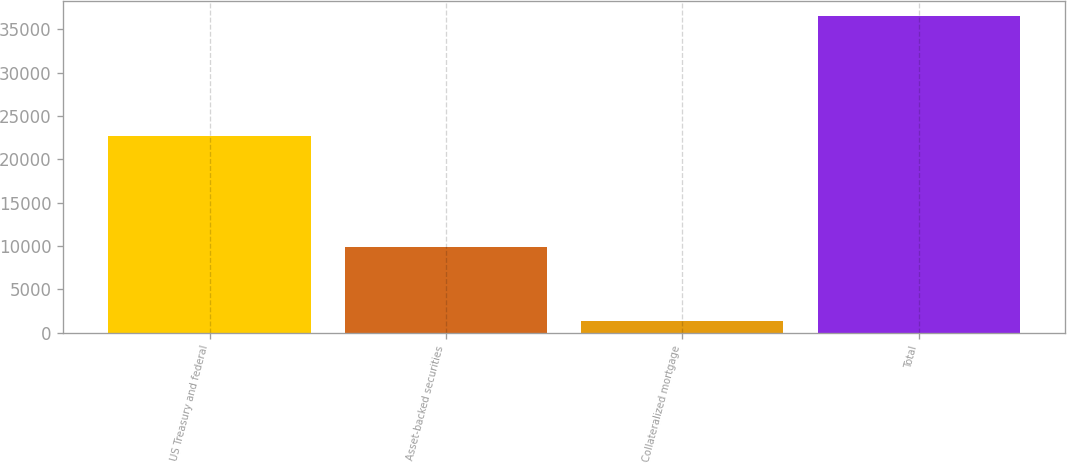<chart> <loc_0><loc_0><loc_500><loc_500><bar_chart><fcel>US Treasury and federal<fcel>Asset-backed securities<fcel>Collateralized mortgage<fcel>Total<nl><fcel>22695<fcel>9852<fcel>1338<fcel>36473<nl></chart> 